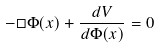Convert formula to latex. <formula><loc_0><loc_0><loc_500><loc_500>- \Box \Phi ( x ) + { \frac { d V } { d \Phi ( x ) } } = 0</formula> 